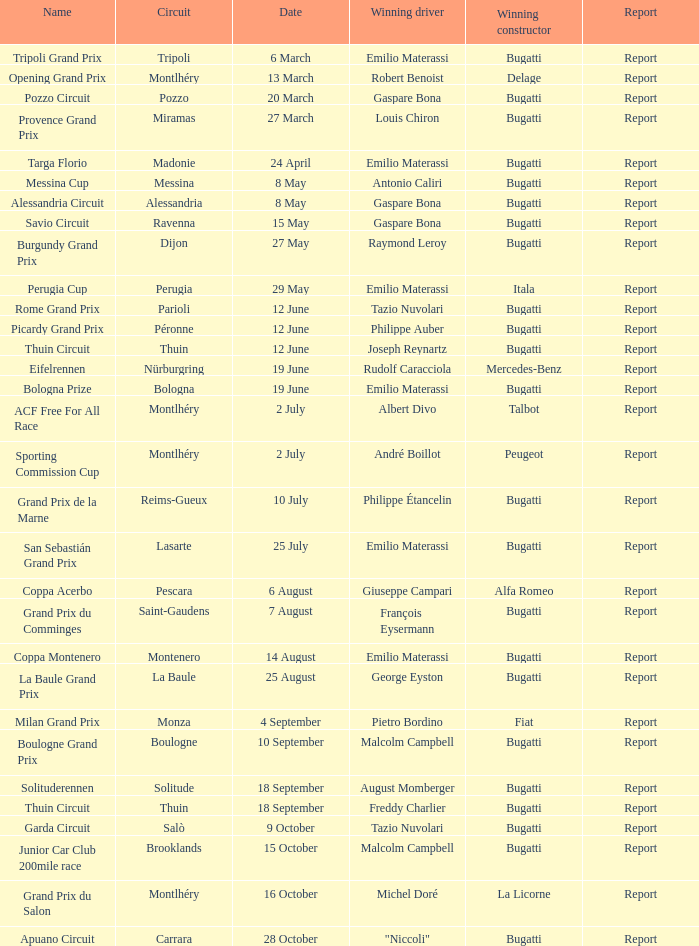Give me the full table as a dictionary. {'header': ['Name', 'Circuit', 'Date', 'Winning driver', 'Winning constructor', 'Report'], 'rows': [['Tripoli Grand Prix', 'Tripoli', '6 March', 'Emilio Materassi', 'Bugatti', 'Report'], ['Opening Grand Prix', 'Montlhéry', '13 March', 'Robert Benoist', 'Delage', 'Report'], ['Pozzo Circuit', 'Pozzo', '20 March', 'Gaspare Bona', 'Bugatti', 'Report'], ['Provence Grand Prix', 'Miramas', '27 March', 'Louis Chiron', 'Bugatti', 'Report'], ['Targa Florio', 'Madonie', '24 April', 'Emilio Materassi', 'Bugatti', 'Report'], ['Messina Cup', 'Messina', '8 May', 'Antonio Caliri', 'Bugatti', 'Report'], ['Alessandria Circuit', 'Alessandria', '8 May', 'Gaspare Bona', 'Bugatti', 'Report'], ['Savio Circuit', 'Ravenna', '15 May', 'Gaspare Bona', 'Bugatti', 'Report'], ['Burgundy Grand Prix', 'Dijon', '27 May', 'Raymond Leroy', 'Bugatti', 'Report'], ['Perugia Cup', 'Perugia', '29 May', 'Emilio Materassi', 'Itala', 'Report'], ['Rome Grand Prix', 'Parioli', '12 June', 'Tazio Nuvolari', 'Bugatti', 'Report'], ['Picardy Grand Prix', 'Péronne', '12 June', 'Philippe Auber', 'Bugatti', 'Report'], ['Thuin Circuit', 'Thuin', '12 June', 'Joseph Reynartz', 'Bugatti', 'Report'], ['Eifelrennen', 'Nürburgring', '19 June', 'Rudolf Caracciola', 'Mercedes-Benz', 'Report'], ['Bologna Prize', 'Bologna', '19 June', 'Emilio Materassi', 'Bugatti', 'Report'], ['ACF Free For All Race', 'Montlhéry', '2 July', 'Albert Divo', 'Talbot', 'Report'], ['Sporting Commission Cup', 'Montlhéry', '2 July', 'André Boillot', 'Peugeot', 'Report'], ['Grand Prix de la Marne', 'Reims-Gueux', '10 July', 'Philippe Étancelin', 'Bugatti', 'Report'], ['San Sebastián Grand Prix', 'Lasarte', '25 July', 'Emilio Materassi', 'Bugatti', 'Report'], ['Coppa Acerbo', 'Pescara', '6 August', 'Giuseppe Campari', 'Alfa Romeo', 'Report'], ['Grand Prix du Comminges', 'Saint-Gaudens', '7 August', 'François Eysermann', 'Bugatti', 'Report'], ['Coppa Montenero', 'Montenero', '14 August', 'Emilio Materassi', 'Bugatti', 'Report'], ['La Baule Grand Prix', 'La Baule', '25 August', 'George Eyston', 'Bugatti', 'Report'], ['Milan Grand Prix', 'Monza', '4 September', 'Pietro Bordino', 'Fiat', 'Report'], ['Boulogne Grand Prix', 'Boulogne', '10 September', 'Malcolm Campbell', 'Bugatti', 'Report'], ['Solituderennen', 'Solitude', '18 September', 'August Momberger', 'Bugatti', 'Report'], ['Thuin Circuit', 'Thuin', '18 September', 'Freddy Charlier', 'Bugatti', 'Report'], ['Garda Circuit', 'Salò', '9 October', 'Tazio Nuvolari', 'Bugatti', 'Report'], ['Junior Car Club 200mile race', 'Brooklands', '15 October', 'Malcolm Campbell', 'Bugatti', 'Report'], ['Grand Prix du Salon', 'Montlhéry', '16 October', 'Michel Doré', 'La Licorne', 'Report'], ['Apuano Circuit', 'Carrara', '28 October', '"Niccoli"', 'Bugatti', 'Report']]} Which circuit did françois eysermann win ? Saint-Gaudens. 